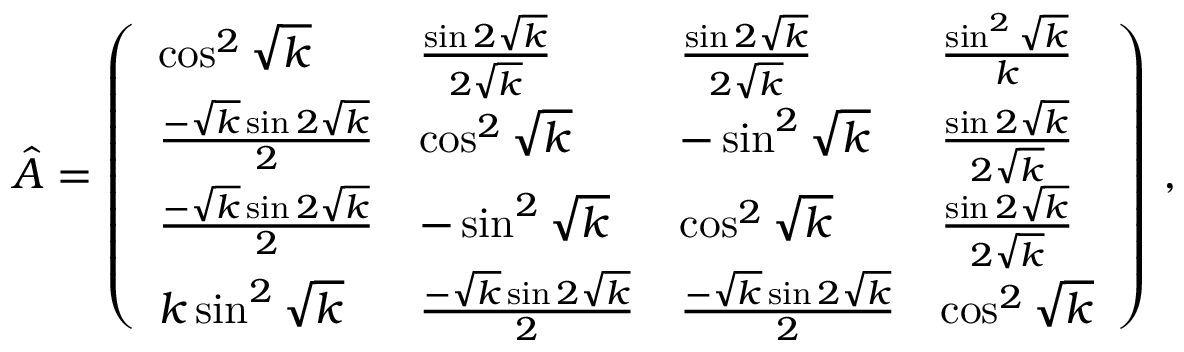<formula> <loc_0><loc_0><loc_500><loc_500>\hat { A } = \left ( \begin{array} { l l l l } { \cos ^ { 2 } \sqrt { k } } & { \frac { \sin 2 \sqrt { k } } { 2 \sqrt { k } } } & { \frac { \sin 2 \sqrt { k } } { 2 \sqrt { k } } } & { \frac { \sin ^ { 2 } \sqrt { k } } { k } } \\ { \frac { - \sqrt { k } \sin 2 \sqrt { k } } { 2 } } & { \cos ^ { 2 } \sqrt { k } } & { - \sin ^ { 2 } \sqrt { k } } & { \frac { \sin 2 \sqrt { k } } { 2 \sqrt { k } } } \\ { \frac { - \sqrt { k } \sin 2 \sqrt { k } } { 2 } } & { - \sin ^ { 2 } \sqrt { k } } & { \cos ^ { 2 } \sqrt { k } } & { \frac { \sin 2 \sqrt { k } } { 2 \sqrt { k } } } \\ { k \sin ^ { 2 } \sqrt { k } } & { \frac { - \sqrt { k } \sin 2 \sqrt { k } } { 2 } } & { \frac { - \sqrt { k } \sin 2 \sqrt { k } } { 2 } } & { \cos ^ { 2 } \sqrt { k } } \end{array} \right ) \, ,</formula> 